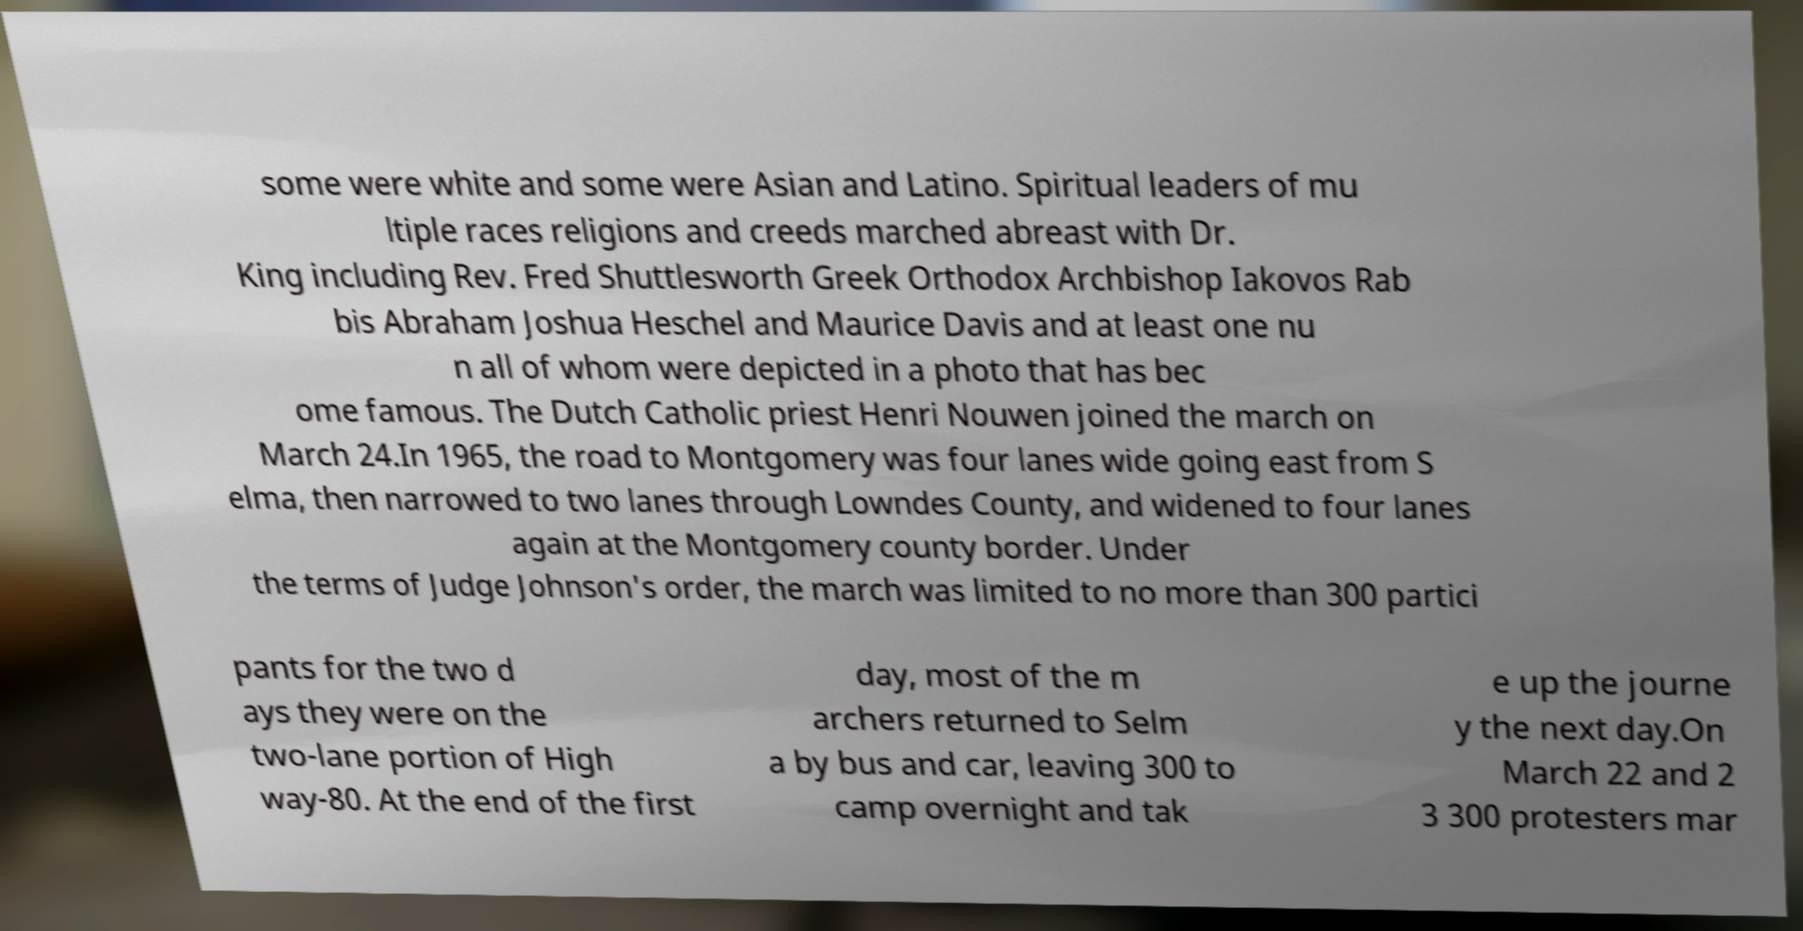Can you read and provide the text displayed in the image?This photo seems to have some interesting text. Can you extract and type it out for me? some were white and some were Asian and Latino. Spiritual leaders of mu ltiple races religions and creeds marched abreast with Dr. King including Rev. Fred Shuttlesworth Greek Orthodox Archbishop Iakovos Rab bis Abraham Joshua Heschel and Maurice Davis and at least one nu n all of whom were depicted in a photo that has bec ome famous. The Dutch Catholic priest Henri Nouwen joined the march on March 24.In 1965, the road to Montgomery was four lanes wide going east from S elma, then narrowed to two lanes through Lowndes County, and widened to four lanes again at the Montgomery county border. Under the terms of Judge Johnson's order, the march was limited to no more than 300 partici pants for the two d ays they were on the two-lane portion of High way-80. At the end of the first day, most of the m archers returned to Selm a by bus and car, leaving 300 to camp overnight and tak e up the journe y the next day.On March 22 and 2 3 300 protesters mar 